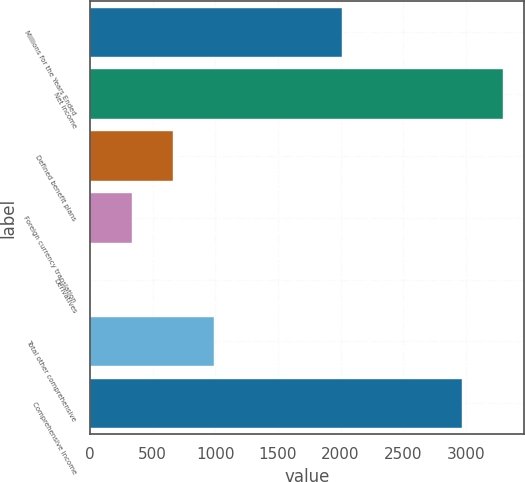<chart> <loc_0><loc_0><loc_500><loc_500><bar_chart><fcel>Millions for the Years Ended<fcel>Net income<fcel>Defined benefit plans<fcel>Foreign currency translation<fcel>Derivatives<fcel>Total other comprehensive<fcel>Comprehensive income<nl><fcel>2011<fcel>3301.1<fcel>659.2<fcel>330.1<fcel>1<fcel>988.3<fcel>2972<nl></chart> 